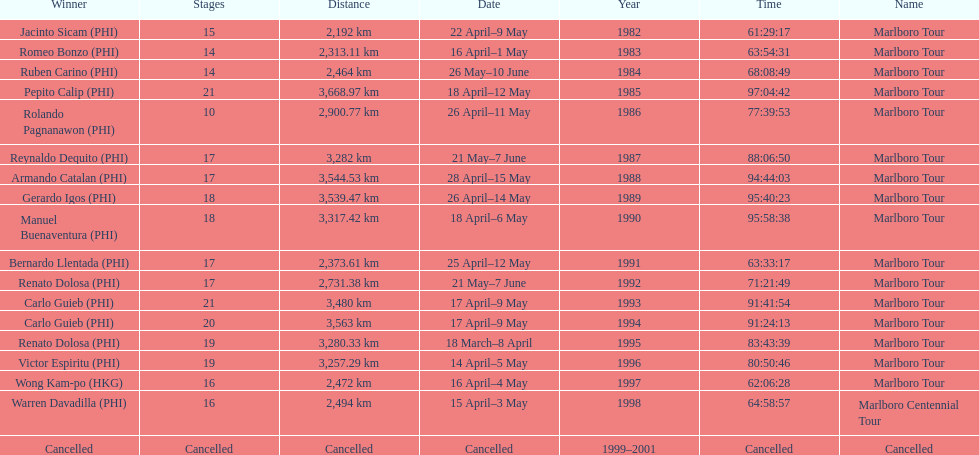Who was the only winner to have their time below 61:45:00? Jacinto Sicam. Would you mind parsing the complete table? {'header': ['Winner', 'Stages', 'Distance', 'Date', 'Year', 'Time', 'Name'], 'rows': [['Jacinto Sicam\xa0(PHI)', '15', '2,192\xa0km', '22 April–9 May', '1982', '61:29:17', 'Marlboro Tour'], ['Romeo Bonzo\xa0(PHI)', '14', '2,313.11\xa0km', '16 April–1 May', '1983', '63:54:31', 'Marlboro Tour'], ['Ruben Carino\xa0(PHI)', '14', '2,464\xa0km', '26 May–10 June', '1984', '68:08:49', 'Marlboro Tour'], ['Pepito Calip\xa0(PHI)', '21', '3,668.97\xa0km', '18 April–12 May', '1985', '97:04:42', 'Marlboro Tour'], ['Rolando Pagnanawon\xa0(PHI)', '10', '2,900.77\xa0km', '26 April–11 May', '1986', '77:39:53', 'Marlboro Tour'], ['Reynaldo Dequito\xa0(PHI)', '17', '3,282\xa0km', '21 May–7 June', '1987', '88:06:50', 'Marlboro Tour'], ['Armando Catalan\xa0(PHI)', '17', '3,544.53\xa0km', '28 April–15 May', '1988', '94:44:03', 'Marlboro Tour'], ['Gerardo Igos\xa0(PHI)', '18', '3,539.47\xa0km', '26 April–14 May', '1989', '95:40:23', 'Marlboro Tour'], ['Manuel Buenaventura\xa0(PHI)', '18', '3,317.42\xa0km', '18 April–6 May', '1990', '95:58:38', 'Marlboro Tour'], ['Bernardo Llentada\xa0(PHI)', '17', '2,373.61\xa0km', '25 April–12 May', '1991', '63:33:17', 'Marlboro Tour'], ['Renato Dolosa\xa0(PHI)', '17', '2,731.38\xa0km', '21 May–7 June', '1992', '71:21:49', 'Marlboro Tour'], ['Carlo Guieb\xa0(PHI)', '21', '3,480\xa0km', '17 April–9 May', '1993', '91:41:54', 'Marlboro Tour'], ['Carlo Guieb\xa0(PHI)', '20', '3,563\xa0km', '17 April–9 May', '1994', '91:24:13', 'Marlboro Tour'], ['Renato Dolosa\xa0(PHI)', '19', '3,280.33\xa0km', '18 March–8 April', '1995', '83:43:39', 'Marlboro Tour'], ['Victor Espiritu\xa0(PHI)', '19', '3,257.29\xa0km', '14 April–5 May', '1996', '80:50:46', 'Marlboro Tour'], ['Wong Kam-po\xa0(HKG)', '16', '2,472\xa0km', '16 April–4 May', '1997', '62:06:28', 'Marlboro Tour'], ['Warren Davadilla\xa0(PHI)', '16', '2,494\xa0km', '15 April–3 May', '1998', '64:58:57', 'Marlboro Centennial Tour'], ['Cancelled', 'Cancelled', 'Cancelled', 'Cancelled', '1999–2001', 'Cancelled', 'Cancelled']]} 